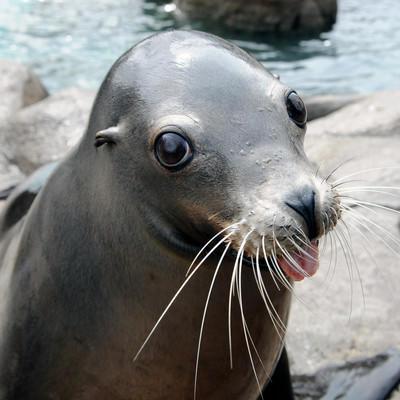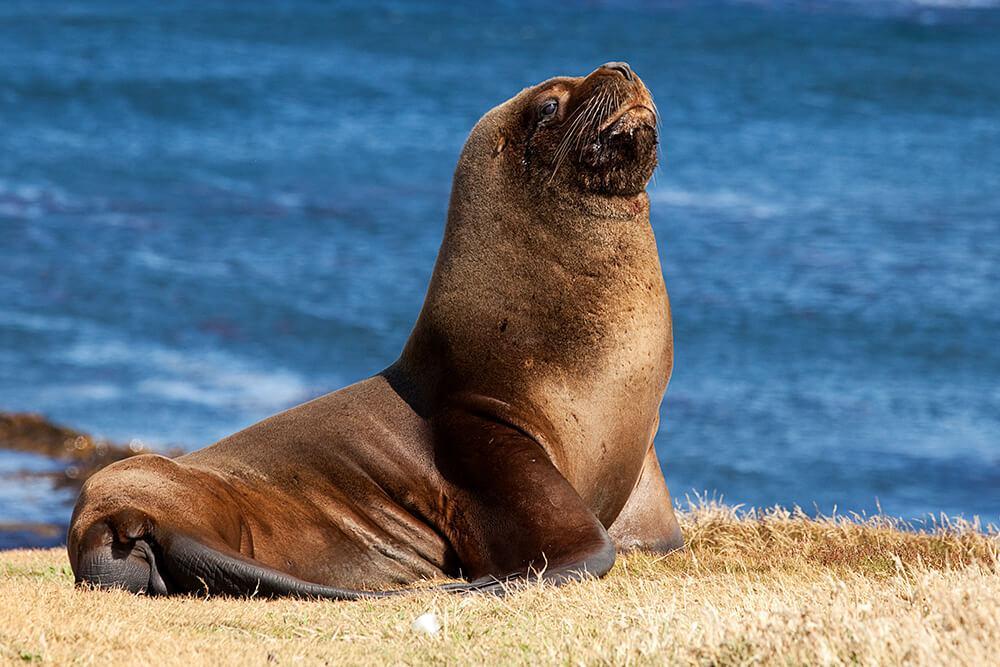The first image is the image on the left, the second image is the image on the right. Evaluate the accuracy of this statement regarding the images: "In one image, there is a seal that appears to be looking directly at the camera.". Is it true? Answer yes or no. Yes. The first image is the image on the left, the second image is the image on the right. Evaluate the accuracy of this statement regarding the images: "there is a body of water on the right image". Is it true? Answer yes or no. Yes. 